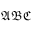<formula> <loc_0><loc_0><loc_500><loc_500>\mathfrak { A B C }</formula> 